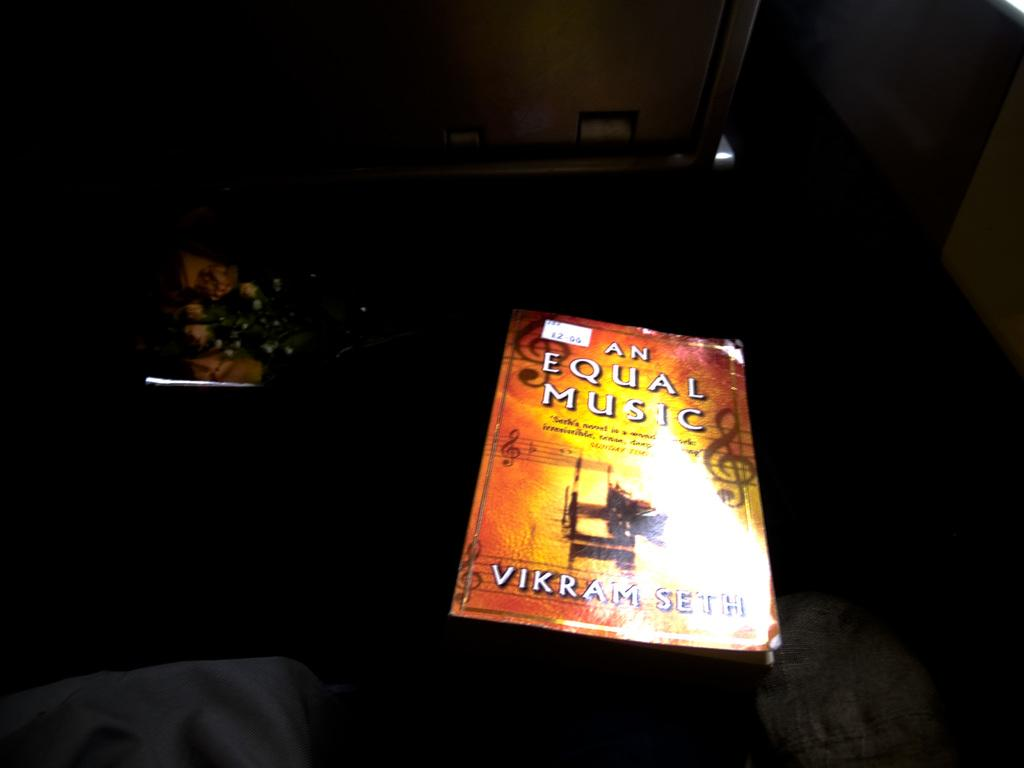Provide a one-sentence caption for the provided image. A book titled An Equal Music has a small price tag on its upper left corner. 